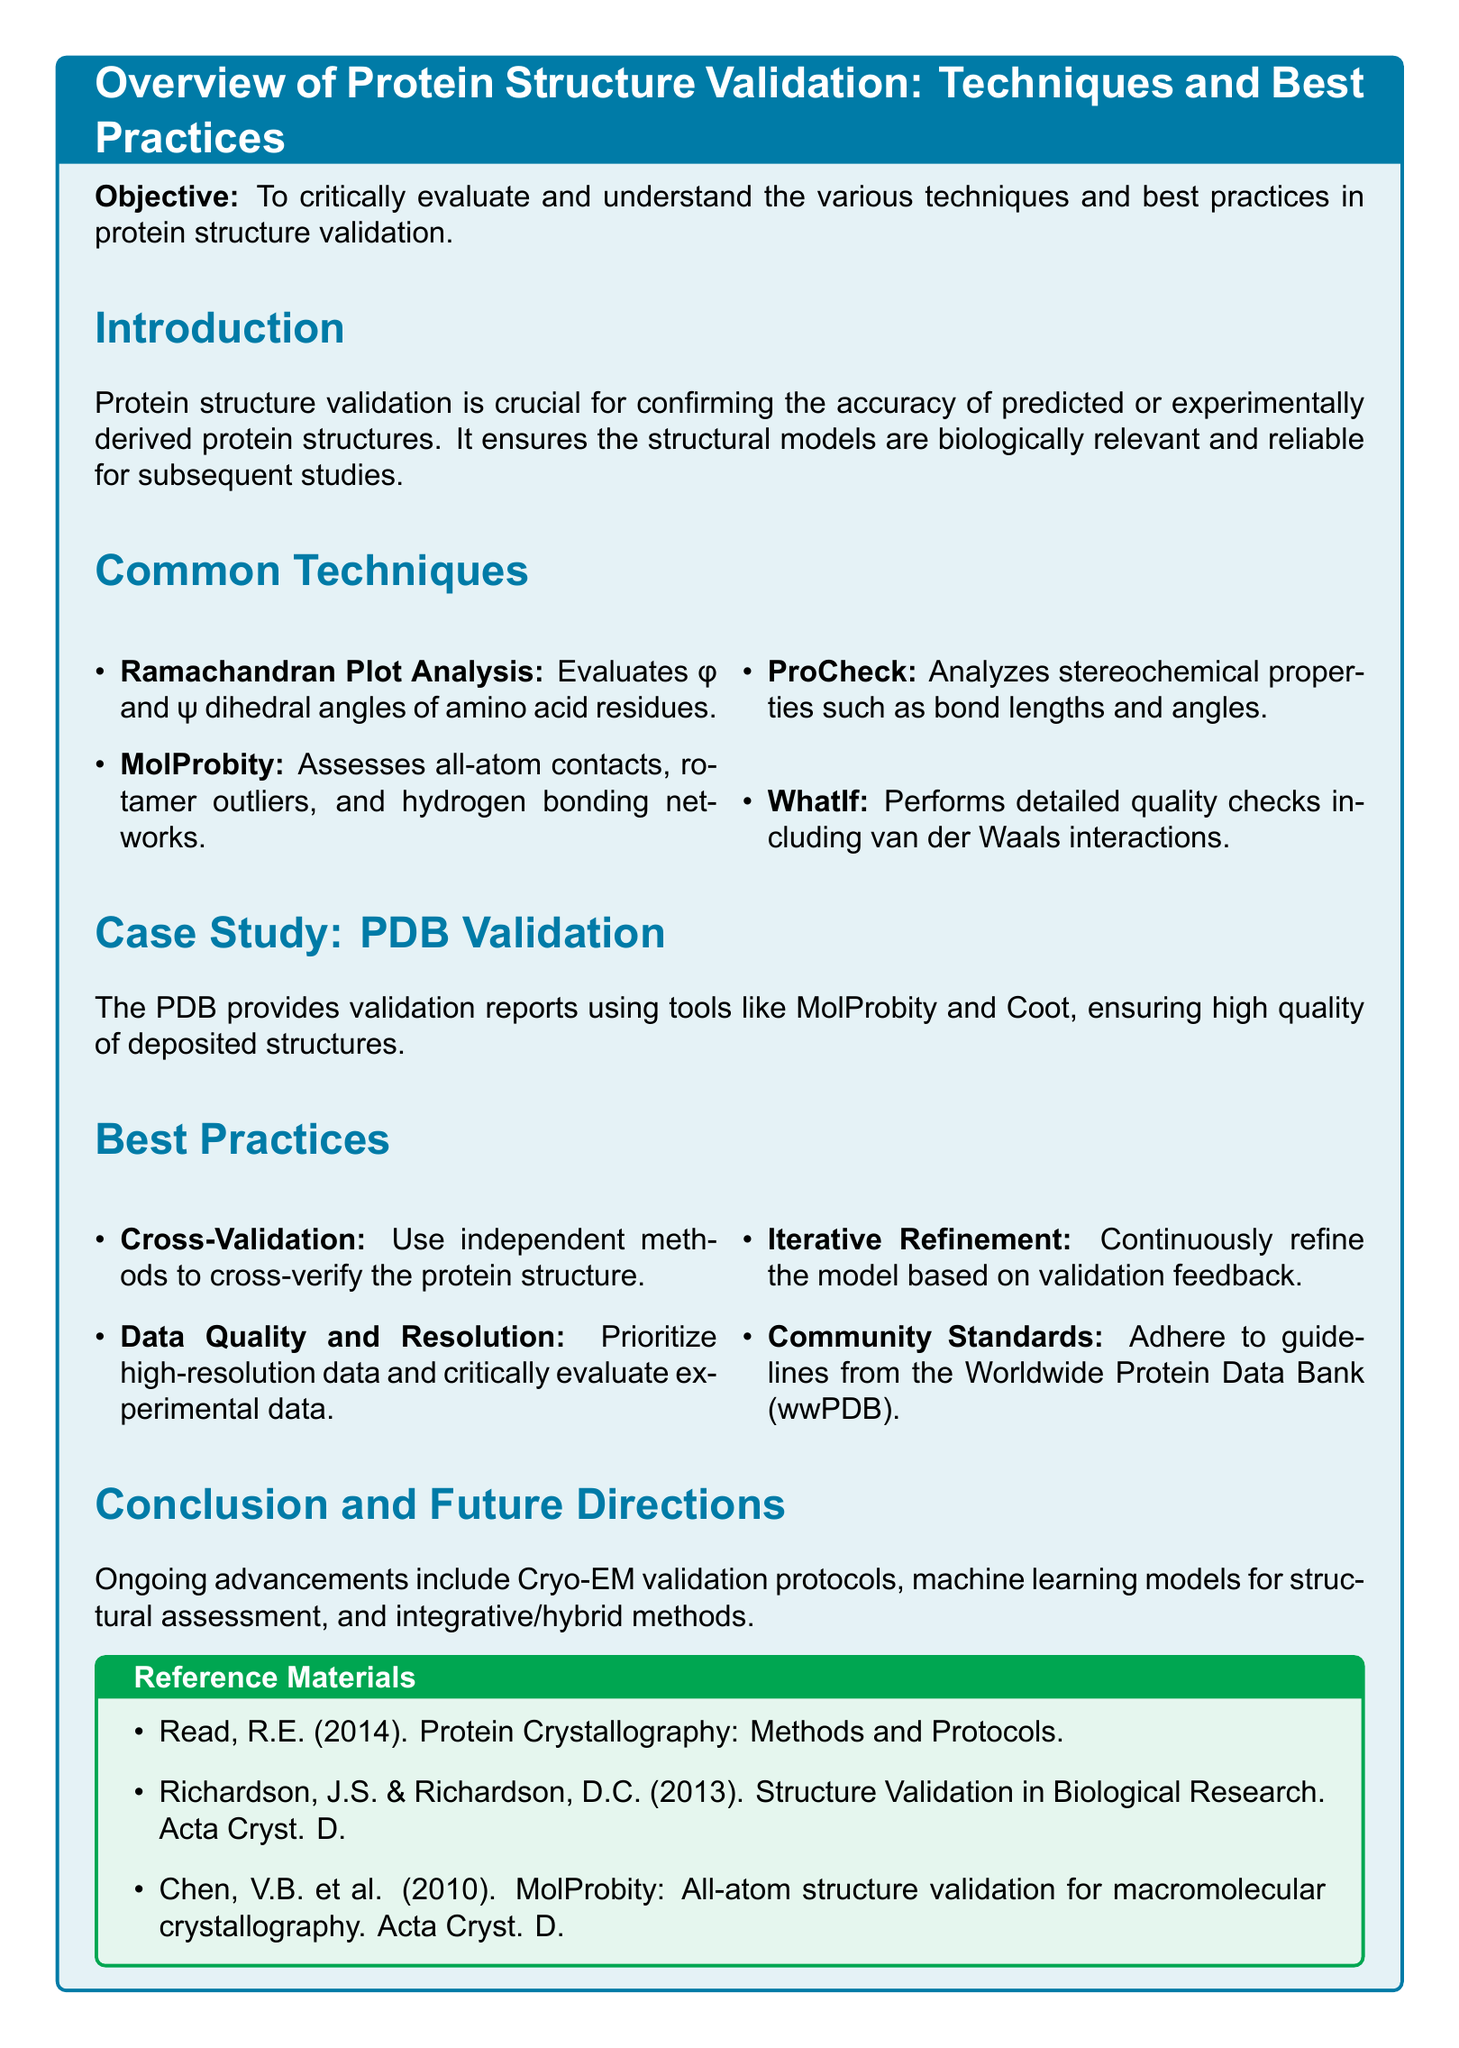what is the objective of this lesson plan? The objective is to critically evaluate and understand the various techniques and best practices in protein structure validation.
Answer: To critically evaluate and understand the various techniques and best practices in protein structure validation how many common techniques are listed in the document? The document lists four common techniques under the "Common Techniques" section.
Answer: Four what is one of the tools used for PDB validation? The document mentions MolProbity as one of the tools used for PDB validation.
Answer: MolProbity name a best practice mentioned in the document. The document includes "Cross-Validation" as one of the best practices in protein structure validation.
Answer: Cross-Validation what protocol is mentioned as an ongoing advancement in validation? The document cites Cryo-EM validation protocols as an ongoing advancement.
Answer: Cryo-EM validation protocols who are the authors of the reference material titled "Structure Validation in Biological Research"? The authors of that material are Richardson, J.S. and Richardson, D.C.
Answer: Richardson, J.S. & Richardson, D.C what is evaluated by Ramachandran Plot Analysis? Ramachandran Plot Analysis evaluates φ and ψ dihedral angles of amino acid residues.
Answer: φ and ψ dihedral angles what should be prioritized according to the best practices section? The best practices section advises prioritizing high-resolution data.
Answer: High-resolution data what is the publication year of the reference titled "MolProbity: All-atom structure validation for macromolecular crystallography"? The publication year is 2010.
Answer: 2010 